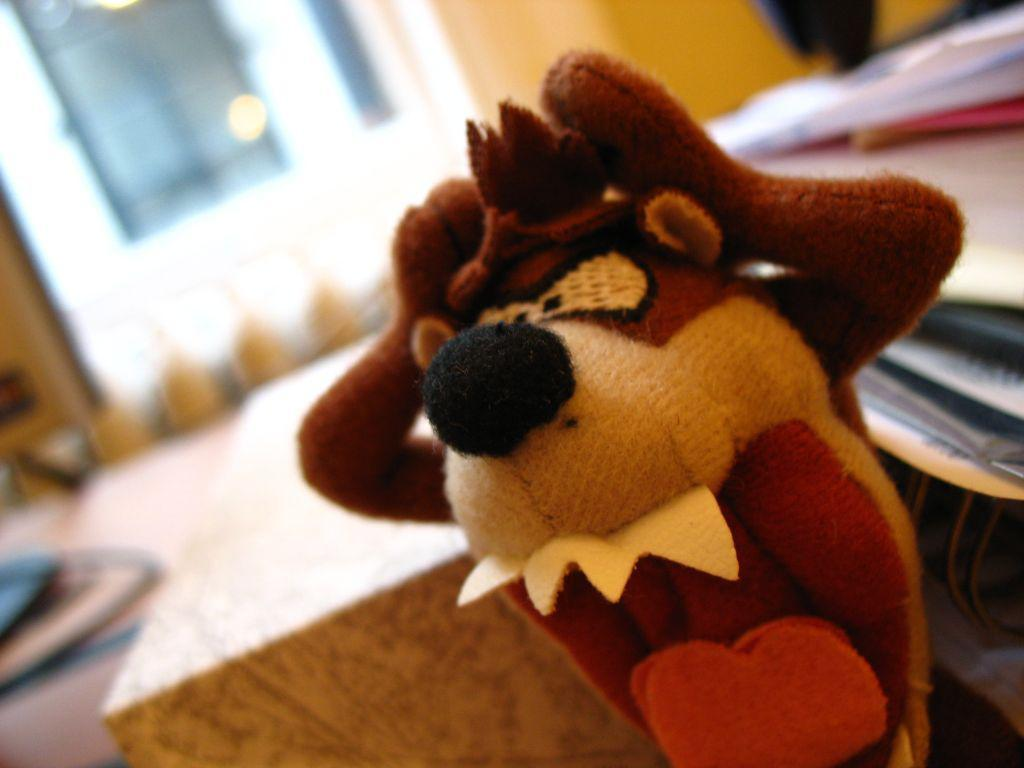What is the main subject in the middle of the image? There is a doll in the middle of the image. Can you describe the background of the image? The background of the image is blurred. What type of food is being prepared in the image? There is no food or preparation visible in the image; it features a doll in the middle of a blurred background. What scientific experiment is being conducted in the image? There is no scientific experiment or indication of one in the image; it features a doll in the middle of a blurred background. 